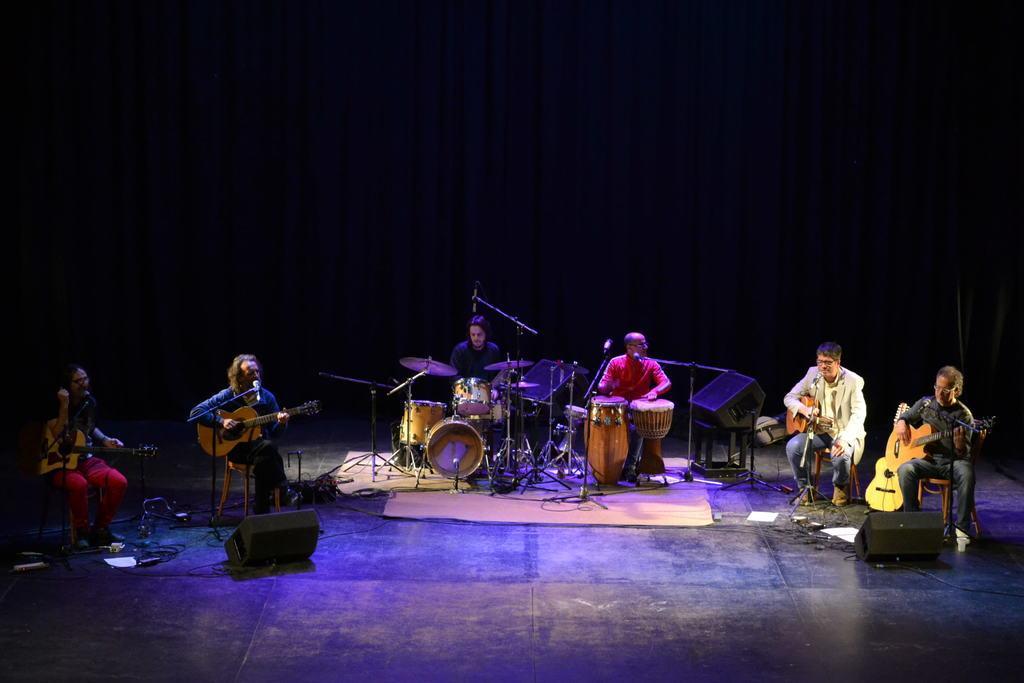Describe this image in one or two sentences. In this picture there is a music band playing a different musical instruments of them, sitting on the stools on the floor. In the background there is a curtain. 